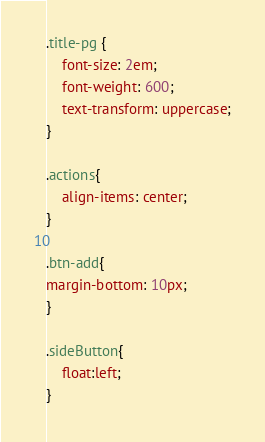Convert code to text. <code><loc_0><loc_0><loc_500><loc_500><_CSS_>.title-pg {
    font-size: 2em;
    font-weight: 600;
    text-transform: uppercase;
}

.actions{
    align-items: center;
}

.btn-add{
margin-bottom: 10px;
}

.sideButton{
    float:left;
}</code> 